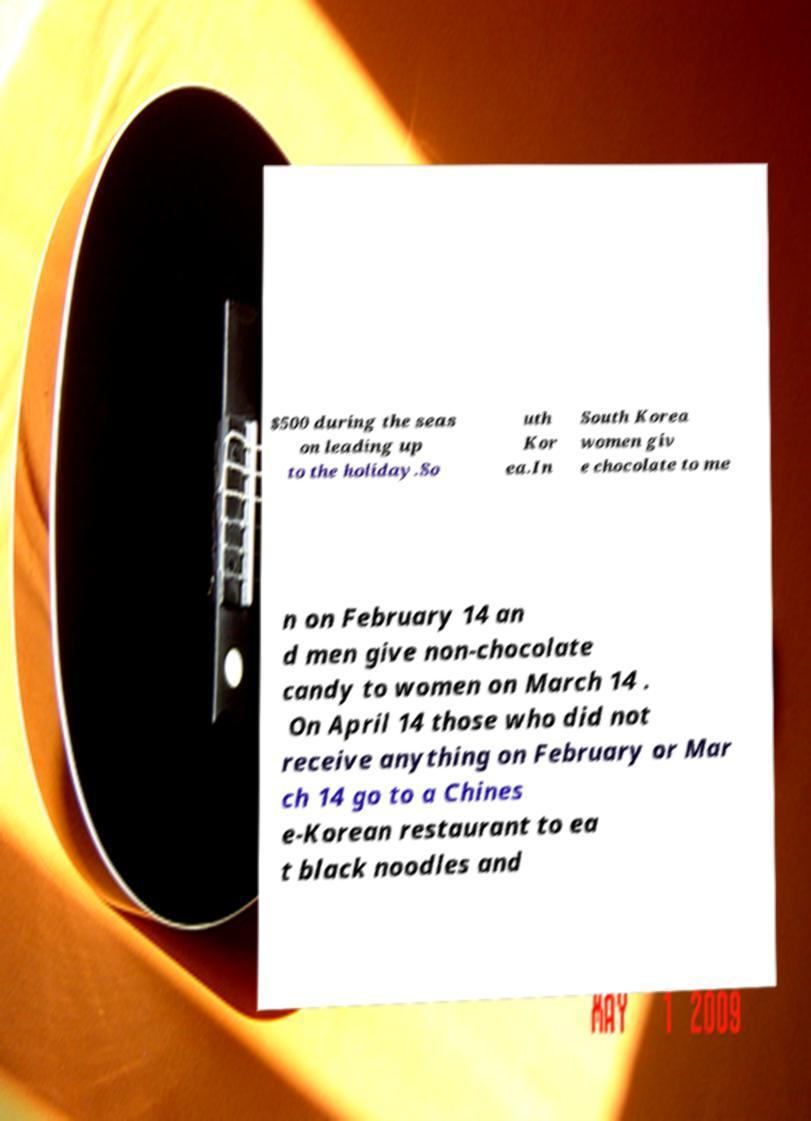I need the written content from this picture converted into text. Can you do that? $500 during the seas on leading up to the holiday.So uth Kor ea.In South Korea women giv e chocolate to me n on February 14 an d men give non-chocolate candy to women on March 14 . On April 14 those who did not receive anything on February or Mar ch 14 go to a Chines e-Korean restaurant to ea t black noodles and 